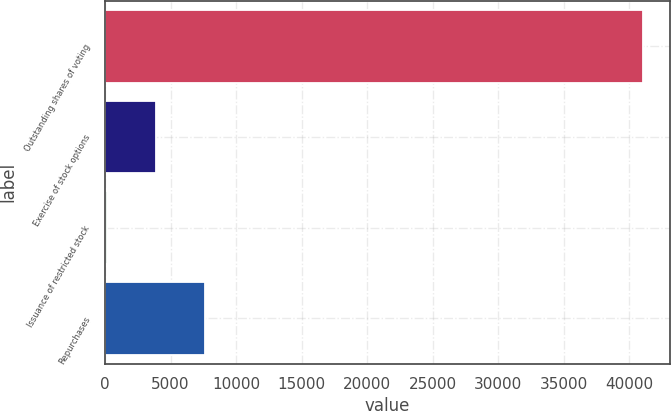Convert chart. <chart><loc_0><loc_0><loc_500><loc_500><bar_chart><fcel>Outstanding shares of voting<fcel>Exercise of stock options<fcel>Issuance of restricted stock<fcel>Repurchases<nl><fcel>41042.1<fcel>3901.1<fcel>178<fcel>7624.2<nl></chart> 